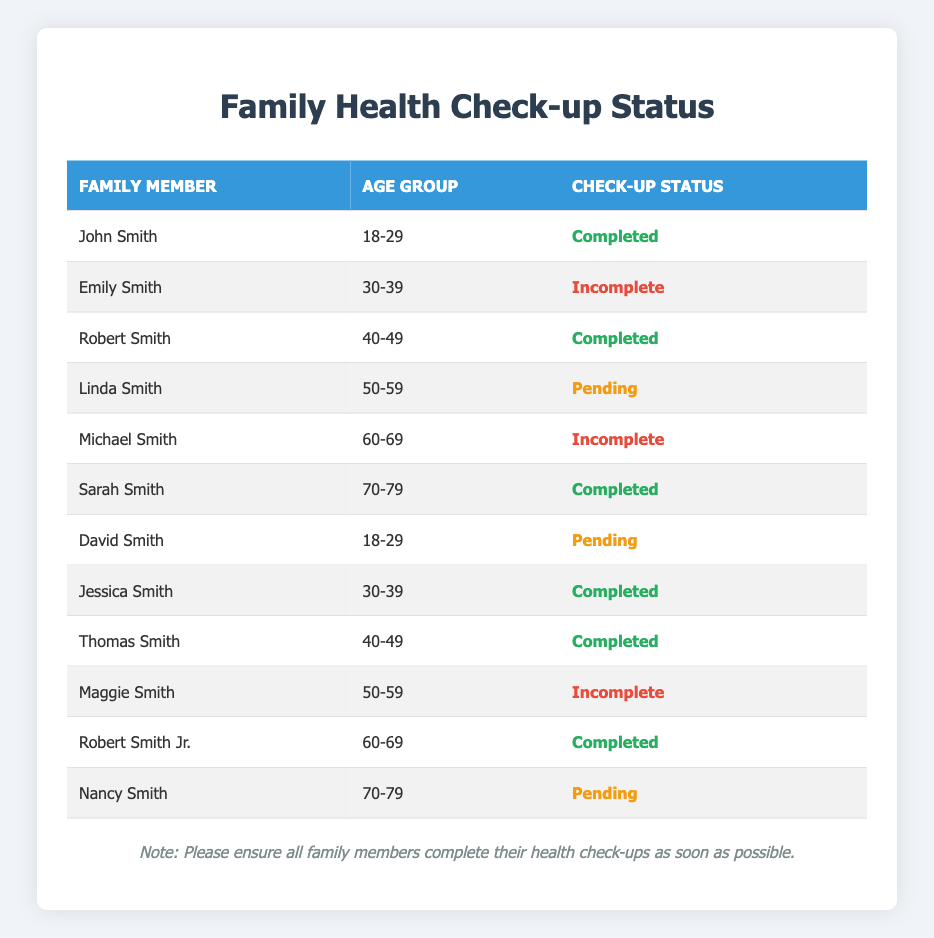What is the check-up status of John Smith? The table shows that John Smith has a check-up status of "Completed." This is found in the row corresponding to John Smith.
Answer: Completed How many family members aged 50-59 have an incomplete check-up status? From the table, there are two family members in the age group 50-59: Linda Smith (Pending) and Maggie Smith (Incomplete). Since we are looking for incomplete status, only Maggie Smith fits, making it a total of one family member.
Answer: 1 Are there any family members aged 70-79 with a completed check-up status? Looking at the rows for the age group 70-79, there are two members: Sarah Smith (Completed) and Nancy Smith (Pending). Since one of them, Sarah Smith, has a "Completed" status, the answer is yes.
Answer: Yes What is the most common check-up status among family members aged 30-39? The table lists two family members in the age group 30-39: Emily Smith (Incomplete) and Jessica Smith (Completed). To determine the most common status, we compare the counts: one "Incomplete" and one "Completed". Since they are equal, we cannot say one is more common than the other, making it unclear.
Answer: Equal How many total family members have a pending check-up status? The rows show that there are three entries with a "Pending" status: Linda Smith (Pending), David Smith (Pending), and Nancy Smith (Pending). Adding these, we find that three family members have a pending status.
Answer: 3 Which age group has the highest number of completed check-ups? There are several age groups represented: 18-29, 30-39, 40-49, and 60-69. By analyzing the respective statuses, 18-29 has 1 Completed (John Smith), 30-39 has 1 Completed (Jessica Smith), 40-49 has 3 Completed (Robert and Thomas), 50-59 has no Completed, 60-69 has 1 (Robert Smith Jr.), and 70-79 has 1 Completed (Sarah). The age group 40-49 stands out with three completed check-ups, which is the highest.
Answer: 40-49 How many family members over the age of 50 have not completed their health check-ups? The age groups beyond 50 include 50-59 (Linda Pending, Maggie Incomplete) and 60-69 (Michael Incomplete, Robert Completed). The incomplete statuses in the age group 50-59 total 2 (Maggie and Linda), and in 60-69, there is 1 (Michael). Thus, adding these gives us a total of three family members over 50 who have not completed their check-ups.
Answer: 3 Is there any family member aged 60-69 who has a pending check-up status? The age group 60-69 includes Michael Smith (Incomplete) and Robert Smith Jr. (Completed). Therefore, there are no family members aged 60-69 with a "Pending" status.
Answer: No Which age group has the lowest number of completed check-ups? The age groups with their completed counts are: 18-29 (1), 30-39 (1), 40-49 (2), 50-59 (0), 60-69 (1), and 70-79 (1). Age group 50-59 has the lowest count, with no completed check-ups.
Answer: 50-59 